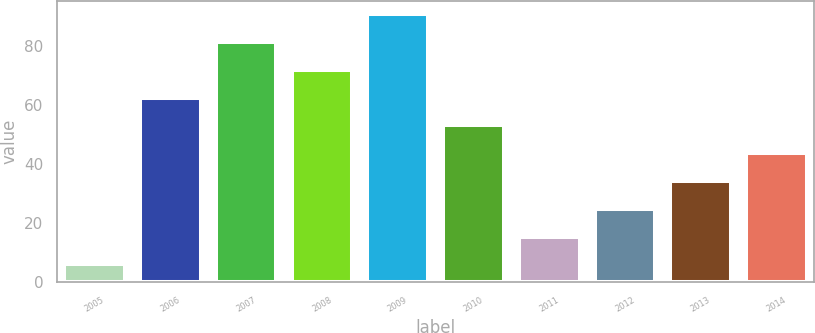Convert chart to OTSL. <chart><loc_0><loc_0><loc_500><loc_500><bar_chart><fcel>2005<fcel>2006<fcel>2007<fcel>2008<fcel>2009<fcel>2010<fcel>2011<fcel>2012<fcel>2013<fcel>2014<nl><fcel>6<fcel>62.4<fcel>81.2<fcel>71.8<fcel>90.6<fcel>53<fcel>15.4<fcel>24.8<fcel>34.2<fcel>43.6<nl></chart> 